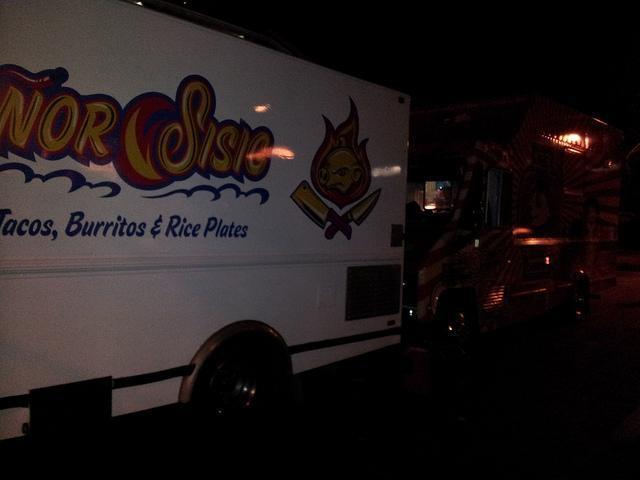How many trucks are there?
Give a very brief answer. 2. How many cakes are on top of the cake caddy?
Give a very brief answer. 0. 